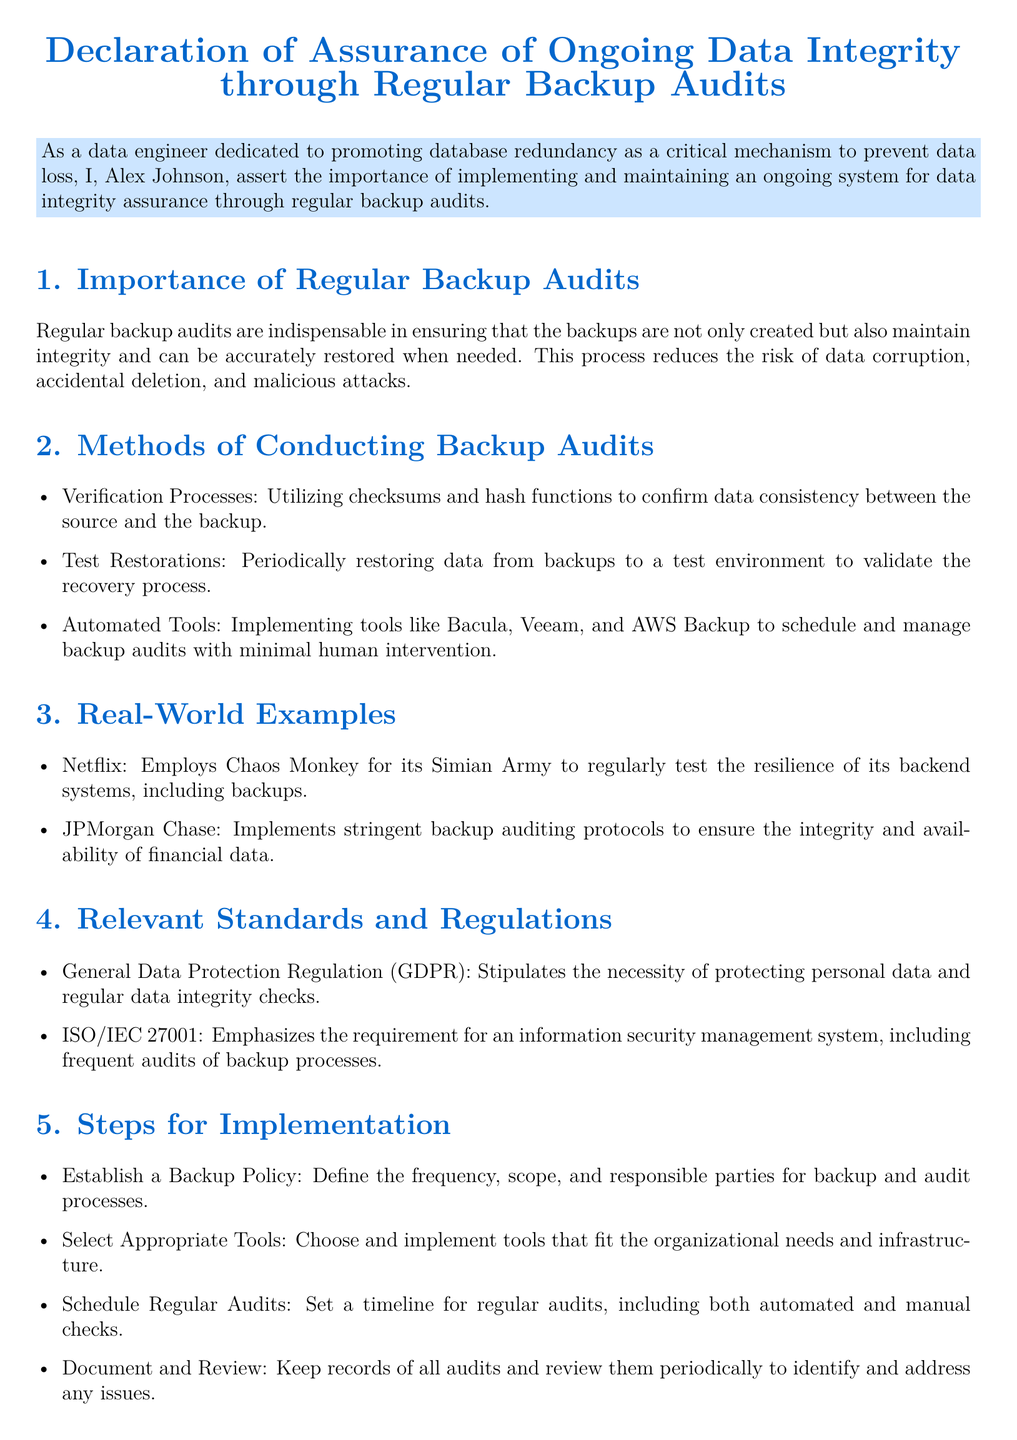What is the name of the declarant? The name of the declarant is stated in the document as Alex Johnson.
Answer: Alex Johnson What is the date of the declaration? The date can be found at the end of the document, indicating when it was signed.
Answer: 2023-10-12 What is the main topic of this declaration? The main topic is indicated in the title of the document about ongoing data integrity assurance.
Answer: Assurance of Ongoing Data Integrity Which regulation emphasizes data integrity checks? This regulation is specifically mentioned in the section about relevant standards and regulations.
Answer: General Data Protection Regulation (GDPR) What tool is mentioned for managing backup audits? The document lists various tools for conducting backup audits, indicating their use in the process.
Answer: Bacula What type of testing does Netflix employ for backup integrity? The document describes a specific method that Netflix uses to ensure the resilience of its systems.
Answer: Chaos Monkey What is the purpose of establishing a backup policy? The document states that establishing a backup policy is part of the steps for implementation.
Answer: Define the frequency, scope, and responsible parties How does the document categorize backup audits? The document includes a section detailing the different aspects or categories related to backup audits.
Answer: Importance of Regular Backup Audits What is the color used for section titles? The document designates a specific color for section titles, which enhances the visual layout.
Answer: maincolor 